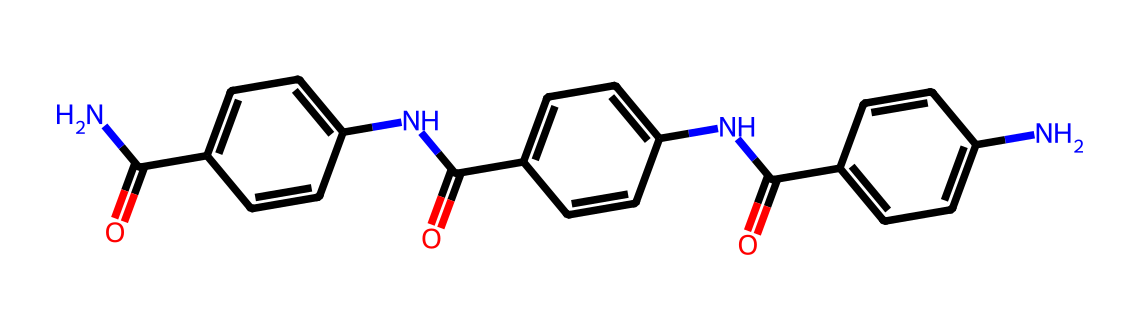How many nitrogen atoms are present in the chemical? Upon examining the SMILES representation, we can identify the presence of nitrogen by searching for "N". In this case, we see "N" occurs twice within the structure, indicating there are two nitrogen atoms in total.
Answer: two What functional groups are present in this chemical? Analyzing the SMILES, we see "C(=O)" which indicates the presence of carbonyl groups (ketones or amides), and "N" which indicates amine or amide groups. Therefore, the functional groups include amide and aromatic rings.
Answer: amide and aromatic rings Is this chemical primarily aromatic or aliphatic? The chemical structure contains several aromatic rings identified by the presence of "c" in the SMILES representation, indicating sp2 hybridization and the potential for resonance. Since the majority of the structure consists of aromatic segments, we conclude it is primarily aromatic.
Answer: aromatic What type of polymer does this chemical represent? The chemical structure includes repeating units of amide bonding and aromatic rings which are characteristic of aramid fibers, known for their high strength and heat resistance, indicating that it is indeed related to polymer materials.
Answer: aramid fibers How many aromatic rings are identifiable in this chemical structure? By examining the SMILES closely, we find three separate occurrences of "c", which indicates aromatic carbon atoms. Each of these implies an aromatic ring. Thus, there are a total of three aromatic rings present in this chemical structure.
Answer: three What feature of the structure contributes to its high strength? The presence of multiple aromatic rings coupled with imide linkages provides significant rigidity and strength to the molecular structure, making it less flexible and much more durable, which is a defining characteristic of high-strength materials.
Answer: aromatic rings and imide linkages 